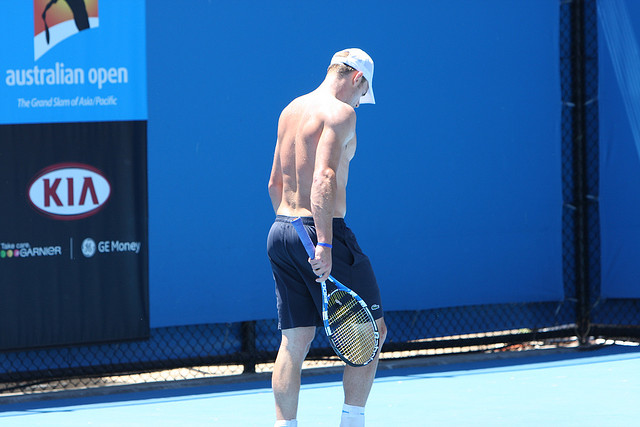Explain the visual content of the image in great detail. The image features a tennis player, seen predominantly on the right side of the picture. He is shirtless, showcasing a muscular build, and is wearing navy blue shorts and a white cap turned backwards. He stands in such a way that his back is mostly visible to the viewer. He holds a tennis racket in his right hand, which hangs loosely at his side. The tennis court floor is a bright blue, with a section of black netting visible behind him, indicating that he is at a tennis facility. The backdrop also includes promotional banners, notably one for the Australian Open, prominently displayed on the left side of the image. The lighting suggests a clear, sunny day, emphasizing the shadows and the brightness of the scene. 